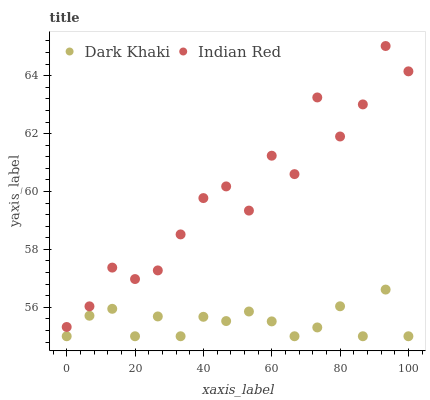Does Dark Khaki have the minimum area under the curve?
Answer yes or no. Yes. Does Indian Red have the maximum area under the curve?
Answer yes or no. Yes. Does Indian Red have the minimum area under the curve?
Answer yes or no. No. Is Dark Khaki the smoothest?
Answer yes or no. Yes. Is Indian Red the roughest?
Answer yes or no. Yes. Is Indian Red the smoothest?
Answer yes or no. No. Does Dark Khaki have the lowest value?
Answer yes or no. Yes. Does Indian Red have the lowest value?
Answer yes or no. No. Does Indian Red have the highest value?
Answer yes or no. Yes. Is Dark Khaki less than Indian Red?
Answer yes or no. Yes. Is Indian Red greater than Dark Khaki?
Answer yes or no. Yes. Does Dark Khaki intersect Indian Red?
Answer yes or no. No. 